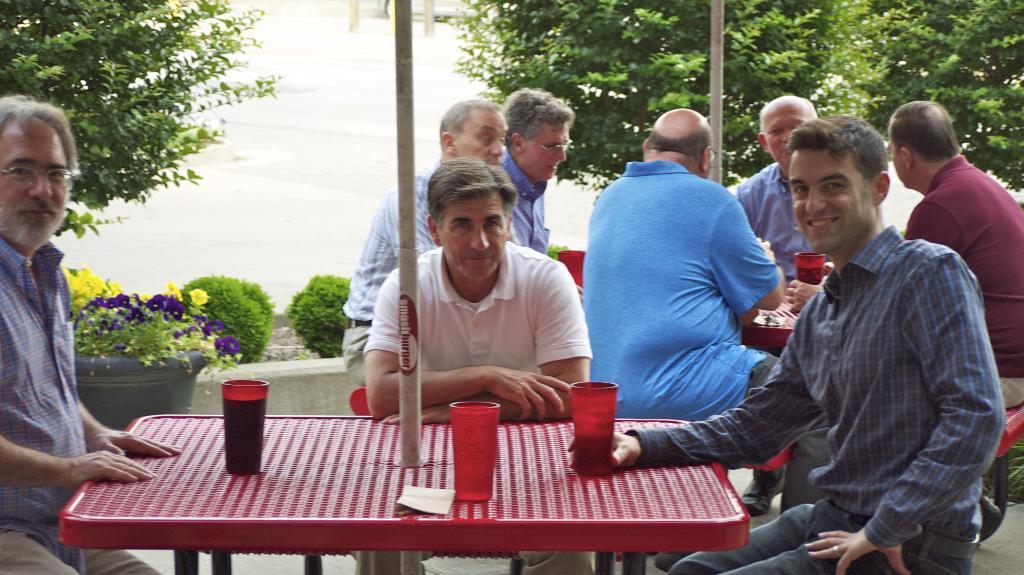How would you summarize this image in a sentence or two? In this image I can see few men are sitting. I can also see smile on his face. Here I can see few tables and on this table I can see few glasses. In the background I can see few trees and few plants. I can also see few of them are wearing specs. 